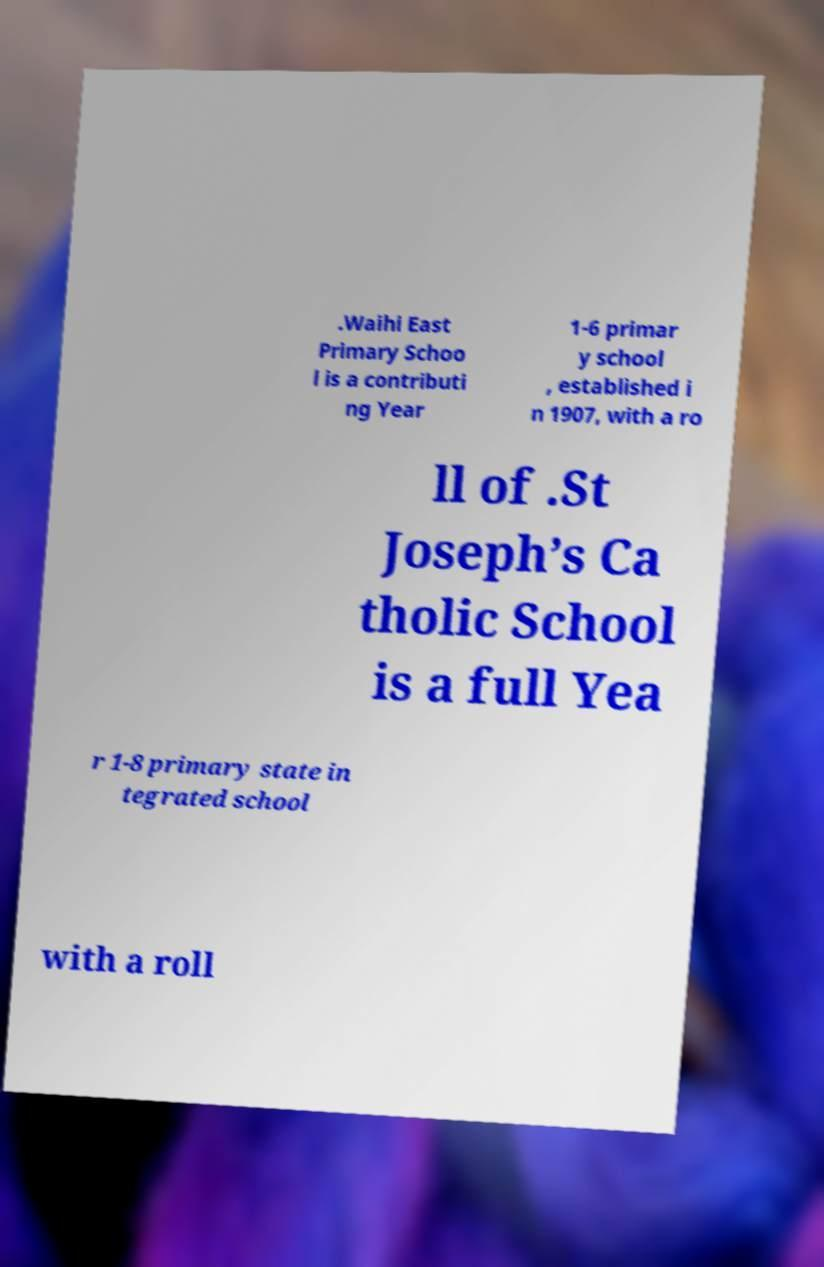Can you read and provide the text displayed in the image?This photo seems to have some interesting text. Can you extract and type it out for me? .Waihi East Primary Schoo l is a contributi ng Year 1-6 primar y school , established i n 1907, with a ro ll of .St Joseph’s Ca tholic School is a full Yea r 1-8 primary state in tegrated school with a roll 